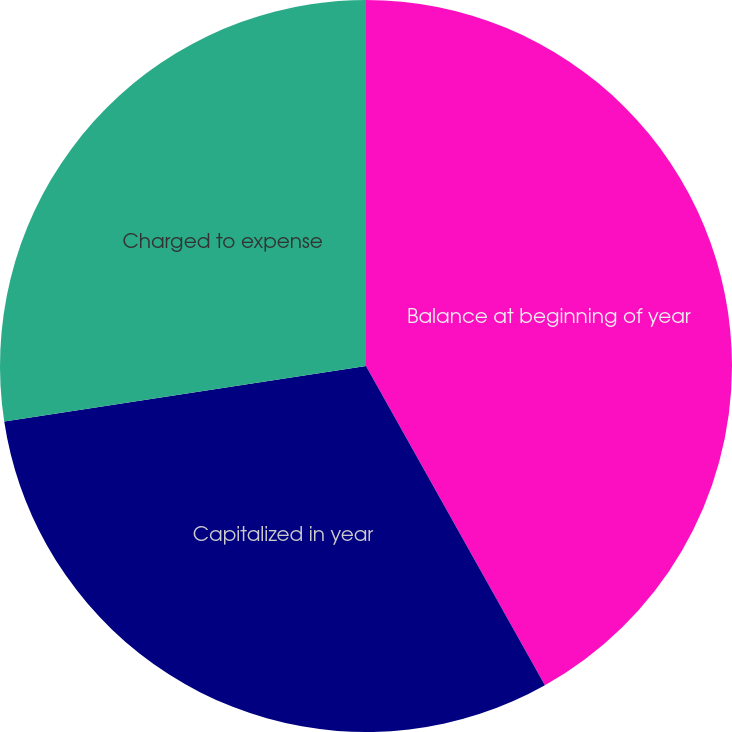Convert chart to OTSL. <chart><loc_0><loc_0><loc_500><loc_500><pie_chart><fcel>Balance at beginning of year<fcel>Capitalized in year<fcel>Charged to expense<nl><fcel>41.87%<fcel>30.71%<fcel>27.42%<nl></chart> 